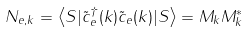Convert formula to latex. <formula><loc_0><loc_0><loc_500><loc_500>N _ { e , k } = \left \langle S | \tilde { c } _ { e } ^ { \dagger } ( k ) \tilde { c } _ { e } ( k ) | S \right \rangle = M _ { k } M _ { k } ^ { * }</formula> 